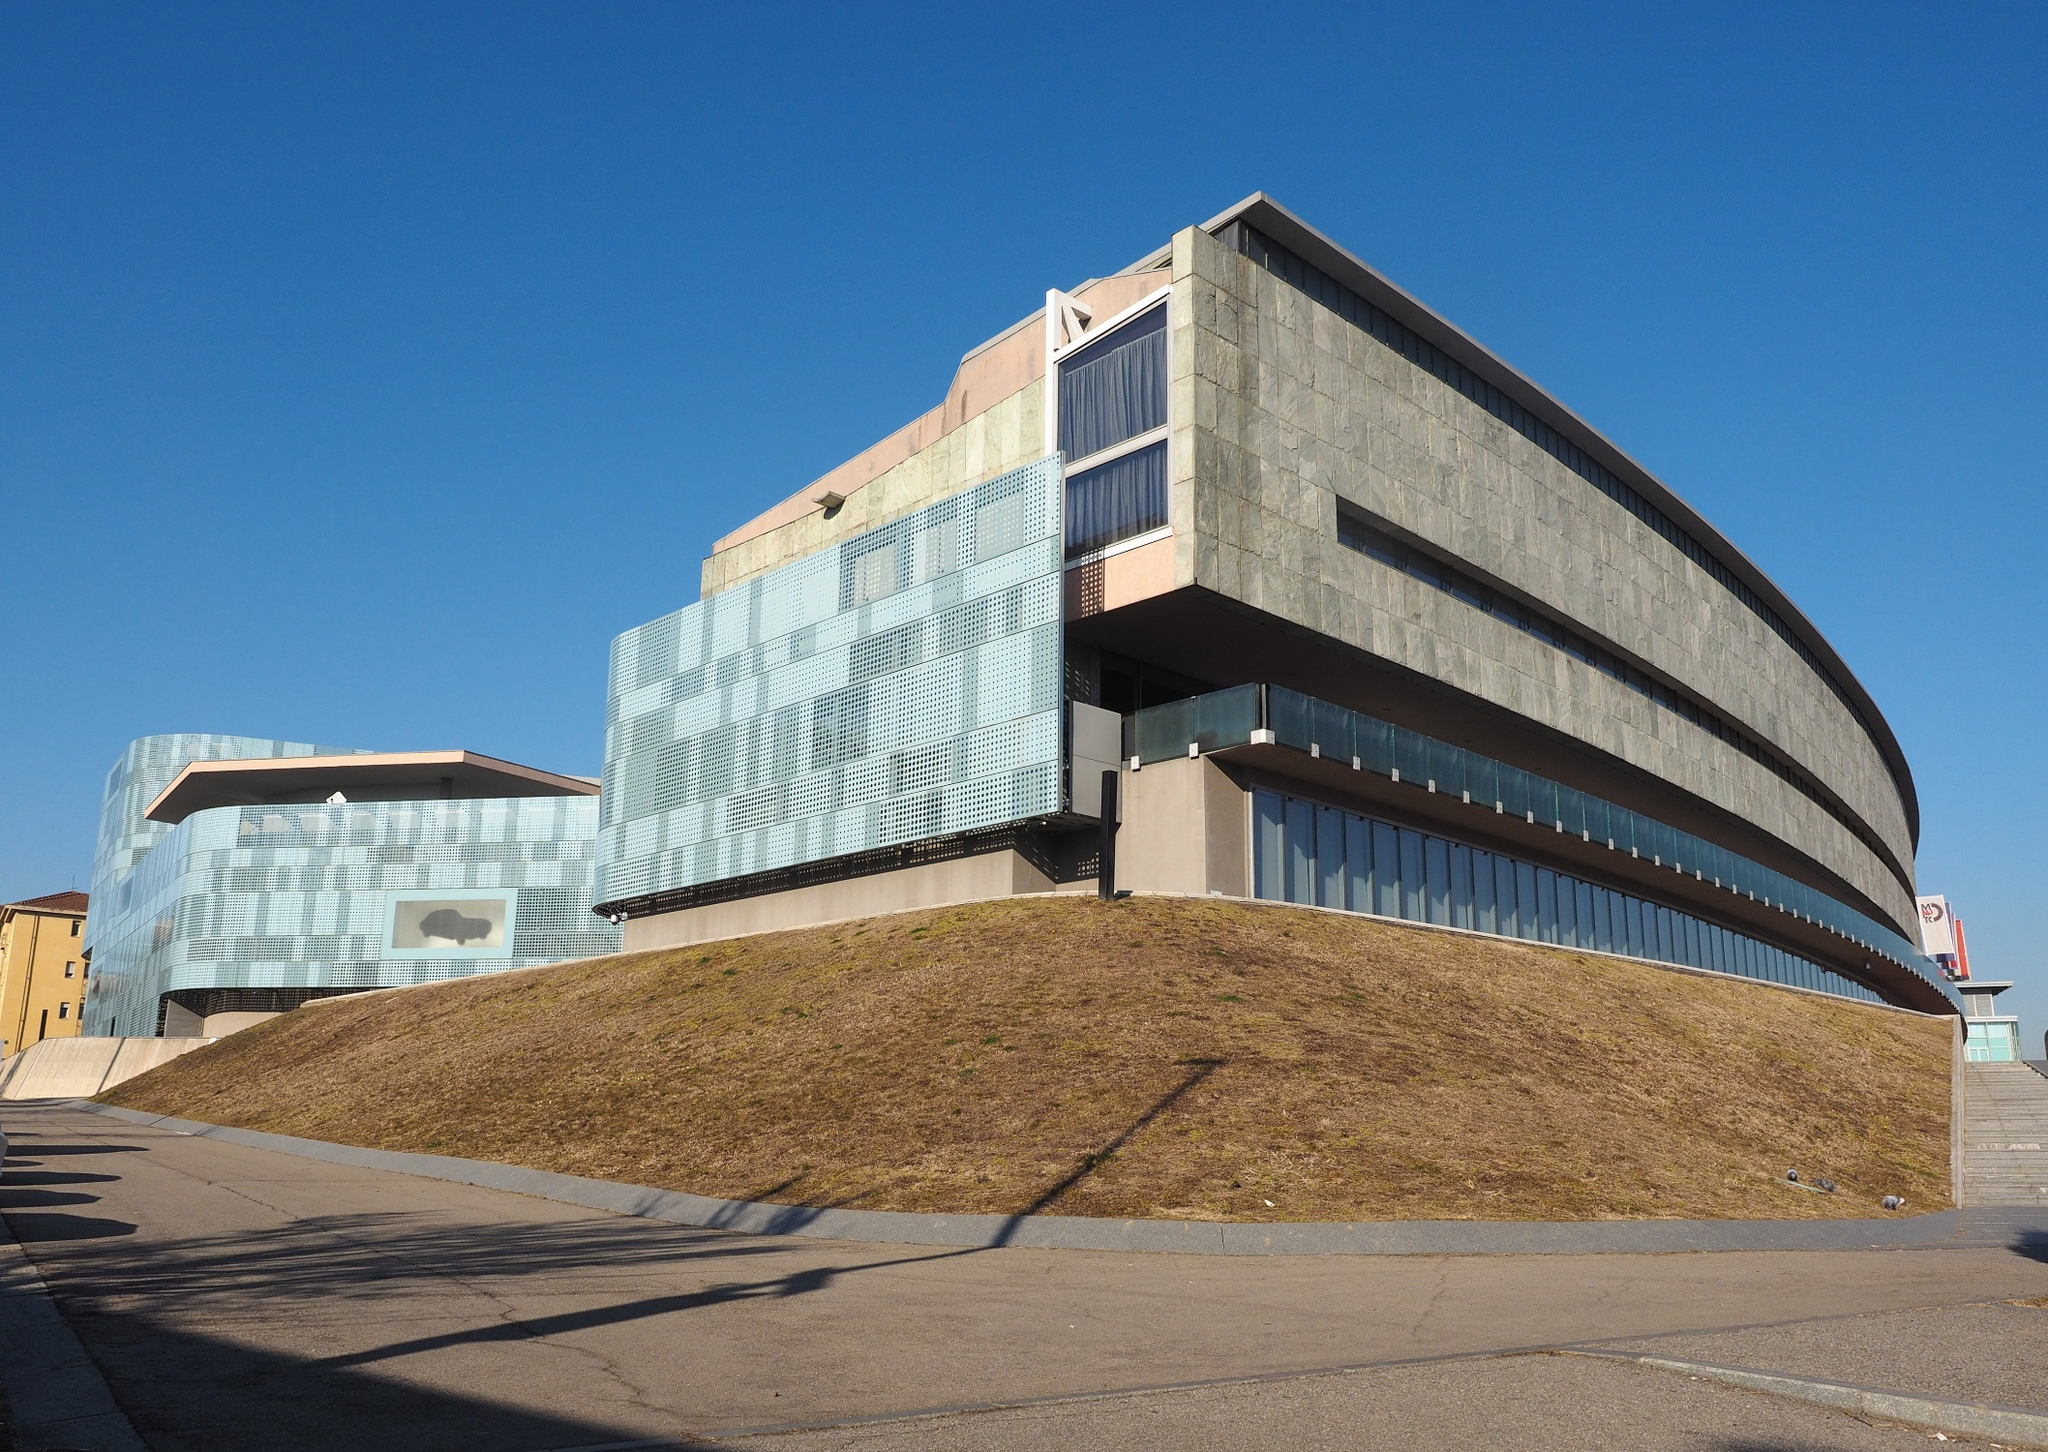Can you elaborate on the possible functional uses of the building shown in the image based on its design? Given its grand scale and modern design, the building might be used for cultural or educational purposes, such as a museum, art gallery, or university building. Its large windows suggest it is designed to invite significant natural light, which is ideal for art displays or to create an open, airy learning environment. The uniqueness of the structure also hints at a landmark status, possibly attracting visitors for its architectural value as well as its contents. 